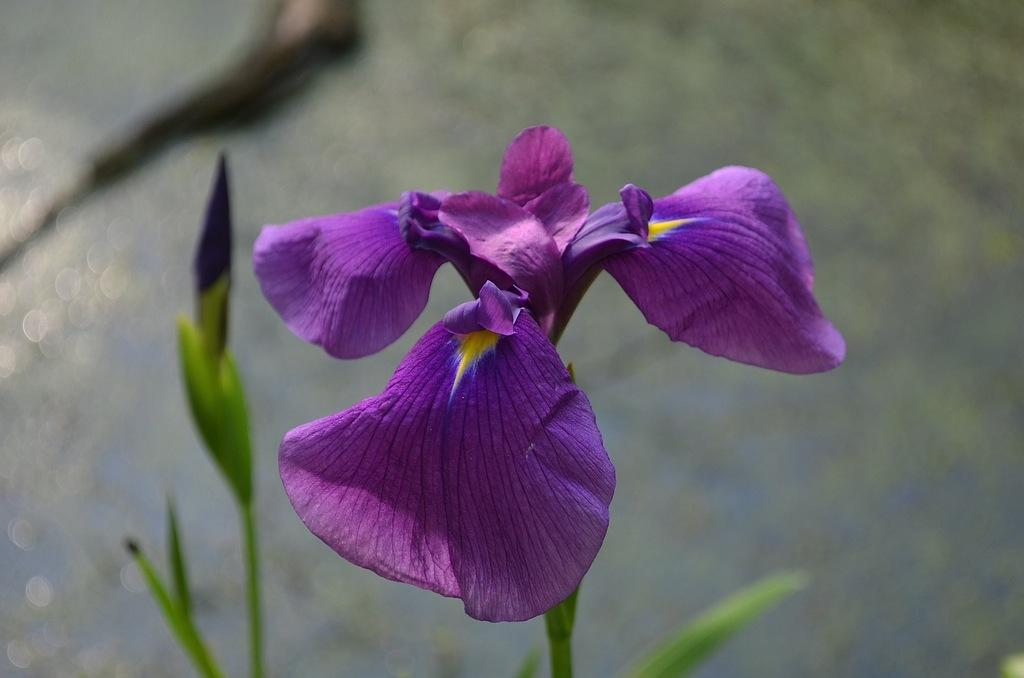What is present in the picture? There is a plant in the picture. What specific features can be observed on the plant? The plant has a flower and a bud. Can you describe the background of the image? The background of the image is blurred. How many apples are hanging from the plant in the image? There are no apples present in the image; it features a plant with a flower and a bud. What type of sticks can be seen supporting the plant in the image? There are no sticks present in the image; it only features a plant with a flower and a bud. 